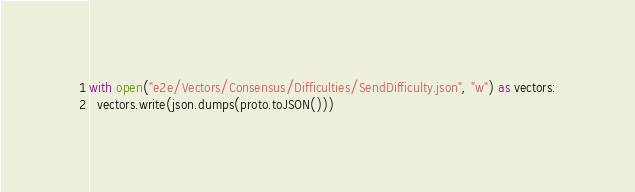<code> <loc_0><loc_0><loc_500><loc_500><_Python_>
with open("e2e/Vectors/Consensus/Difficulties/SendDifficulty.json", "w") as vectors:
  vectors.write(json.dumps(proto.toJSON()))
</code> 